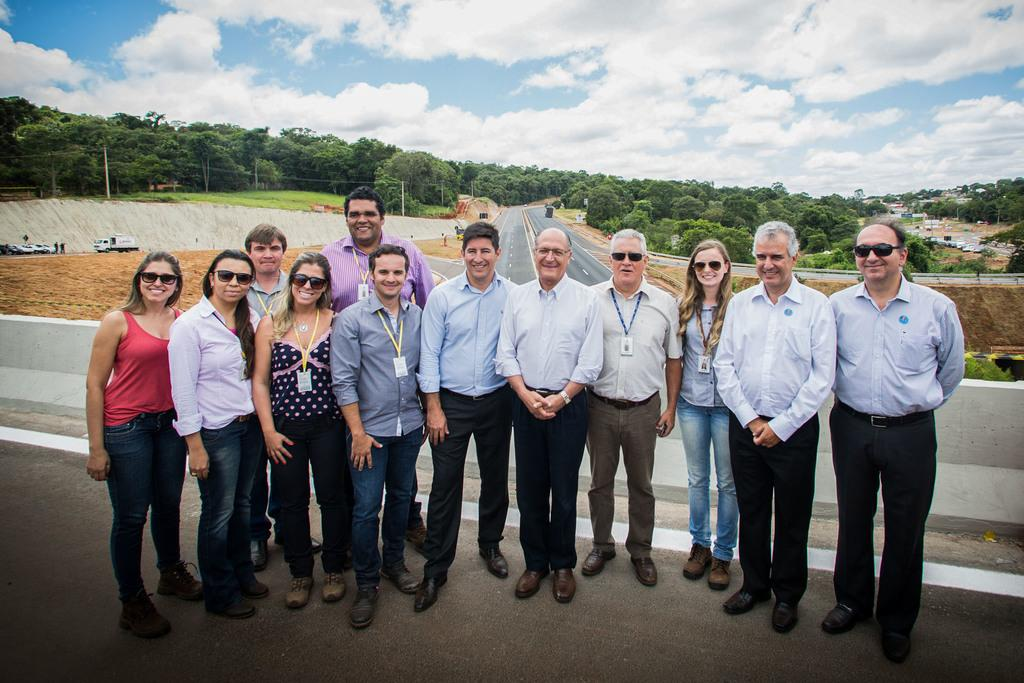What are the people in the image doing? The people in the image are standing on a bridge. What can be seen in the background of the image? In the background of the image, there are vehicles, roads, trees, and the sky. Can you describe the setting of the image? The image is set on a bridge with a background that includes roads, trees, and the sky. What type of food is being served under the shade of the trees in the image? There is no food or shade present in the image; it features people standing on a bridge with a background that includes roads, trees, and the sky. 